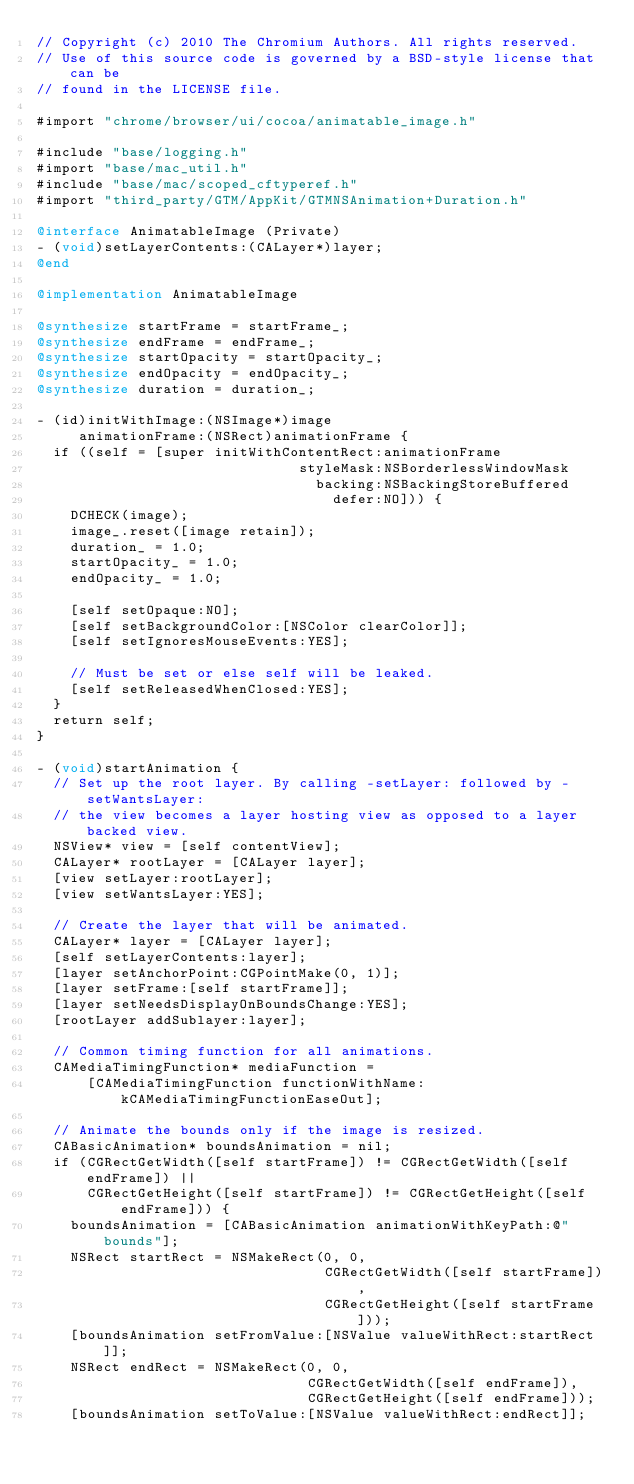Convert code to text. <code><loc_0><loc_0><loc_500><loc_500><_ObjectiveC_>// Copyright (c) 2010 The Chromium Authors. All rights reserved.
// Use of this source code is governed by a BSD-style license that can be
// found in the LICENSE file.

#import "chrome/browser/ui/cocoa/animatable_image.h"

#include "base/logging.h"
#import "base/mac_util.h"
#include "base/mac/scoped_cftyperef.h"
#import "third_party/GTM/AppKit/GTMNSAnimation+Duration.h"

@interface AnimatableImage (Private)
- (void)setLayerContents:(CALayer*)layer;
@end

@implementation AnimatableImage

@synthesize startFrame = startFrame_;
@synthesize endFrame = endFrame_;
@synthesize startOpacity = startOpacity_;
@synthesize endOpacity = endOpacity_;
@synthesize duration = duration_;

- (id)initWithImage:(NSImage*)image
     animationFrame:(NSRect)animationFrame {
  if ((self = [super initWithContentRect:animationFrame
                               styleMask:NSBorderlessWindowMask
                                 backing:NSBackingStoreBuffered
                                   defer:NO])) {
    DCHECK(image);
    image_.reset([image retain]);
    duration_ = 1.0;
    startOpacity_ = 1.0;
    endOpacity_ = 1.0;

    [self setOpaque:NO];
    [self setBackgroundColor:[NSColor clearColor]];
    [self setIgnoresMouseEvents:YES];

    // Must be set or else self will be leaked.
    [self setReleasedWhenClosed:YES];
  }
  return self;
}

- (void)startAnimation {
  // Set up the root layer. By calling -setLayer: followed by -setWantsLayer:
  // the view becomes a layer hosting view as opposed to a layer backed view.
  NSView* view = [self contentView];
  CALayer* rootLayer = [CALayer layer];
  [view setLayer:rootLayer];
  [view setWantsLayer:YES];

  // Create the layer that will be animated.
  CALayer* layer = [CALayer layer];
  [self setLayerContents:layer];
  [layer setAnchorPoint:CGPointMake(0, 1)];
  [layer setFrame:[self startFrame]];
  [layer setNeedsDisplayOnBoundsChange:YES];
  [rootLayer addSublayer:layer];

  // Common timing function for all animations.
  CAMediaTimingFunction* mediaFunction =
      [CAMediaTimingFunction functionWithName:kCAMediaTimingFunctionEaseOut];

  // Animate the bounds only if the image is resized.
  CABasicAnimation* boundsAnimation = nil;
  if (CGRectGetWidth([self startFrame]) != CGRectGetWidth([self endFrame]) ||
      CGRectGetHeight([self startFrame]) != CGRectGetHeight([self endFrame])) {
    boundsAnimation = [CABasicAnimation animationWithKeyPath:@"bounds"];
    NSRect startRect = NSMakeRect(0, 0,
                                  CGRectGetWidth([self startFrame]),
                                  CGRectGetHeight([self startFrame]));
    [boundsAnimation setFromValue:[NSValue valueWithRect:startRect]];
    NSRect endRect = NSMakeRect(0, 0,
                                CGRectGetWidth([self endFrame]),
                                CGRectGetHeight([self endFrame]));
    [boundsAnimation setToValue:[NSValue valueWithRect:endRect]];</code> 